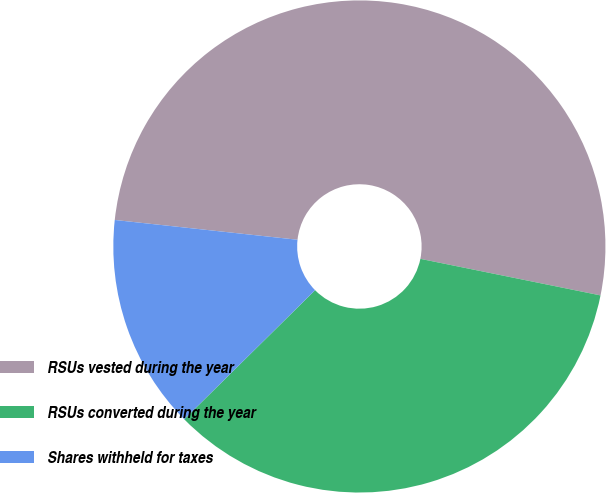<chart> <loc_0><loc_0><loc_500><loc_500><pie_chart><fcel>RSUs vested during the year<fcel>RSUs converted during the year<fcel>Shares withheld for taxes<nl><fcel>51.47%<fcel>34.42%<fcel>14.11%<nl></chart> 